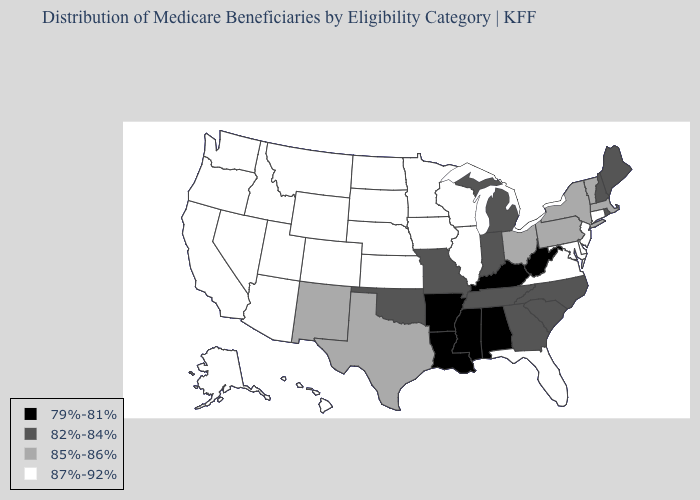What is the value of Michigan?
Quick response, please. 82%-84%. What is the highest value in the USA?
Short answer required. 87%-92%. Does the first symbol in the legend represent the smallest category?
Be succinct. Yes. Name the states that have a value in the range 79%-81%?
Quick response, please. Alabama, Arkansas, Kentucky, Louisiana, Mississippi, West Virginia. Does Illinois have the highest value in the USA?
Write a very short answer. Yes. What is the lowest value in states that border Delaware?
Answer briefly. 85%-86%. What is the lowest value in states that border Massachusetts?
Quick response, please. 82%-84%. What is the highest value in the USA?
Keep it brief. 87%-92%. Does West Virginia have the lowest value in the USA?
Answer briefly. Yes. What is the value of Washington?
Answer briefly. 87%-92%. What is the value of California?
Be succinct. 87%-92%. Name the states that have a value in the range 82%-84%?
Be succinct. Georgia, Indiana, Maine, Michigan, Missouri, New Hampshire, North Carolina, Oklahoma, Rhode Island, South Carolina, Tennessee. How many symbols are there in the legend?
Keep it brief. 4. Among the states that border Michigan , which have the lowest value?
Quick response, please. Indiana. What is the highest value in the West ?
Quick response, please. 87%-92%. 